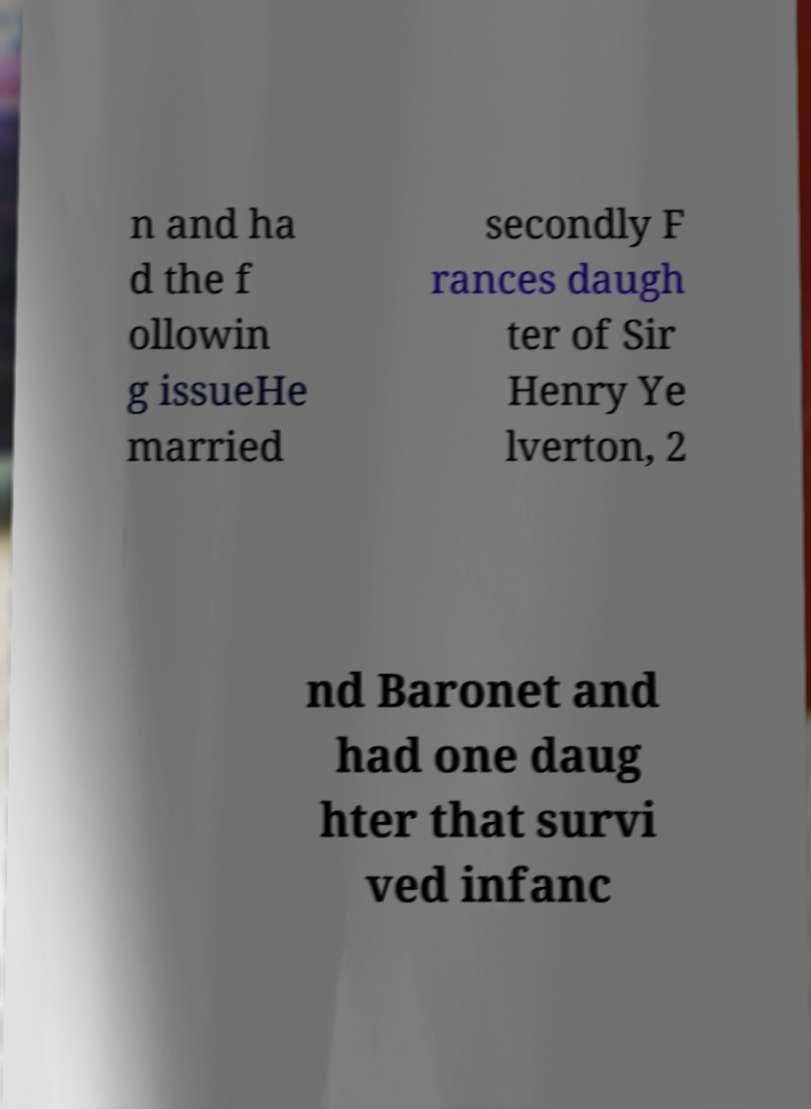There's text embedded in this image that I need extracted. Can you transcribe it verbatim? n and ha d the f ollowin g issueHe married secondly F rances daugh ter of Sir Henry Ye lverton, 2 nd Baronet and had one daug hter that survi ved infanc 